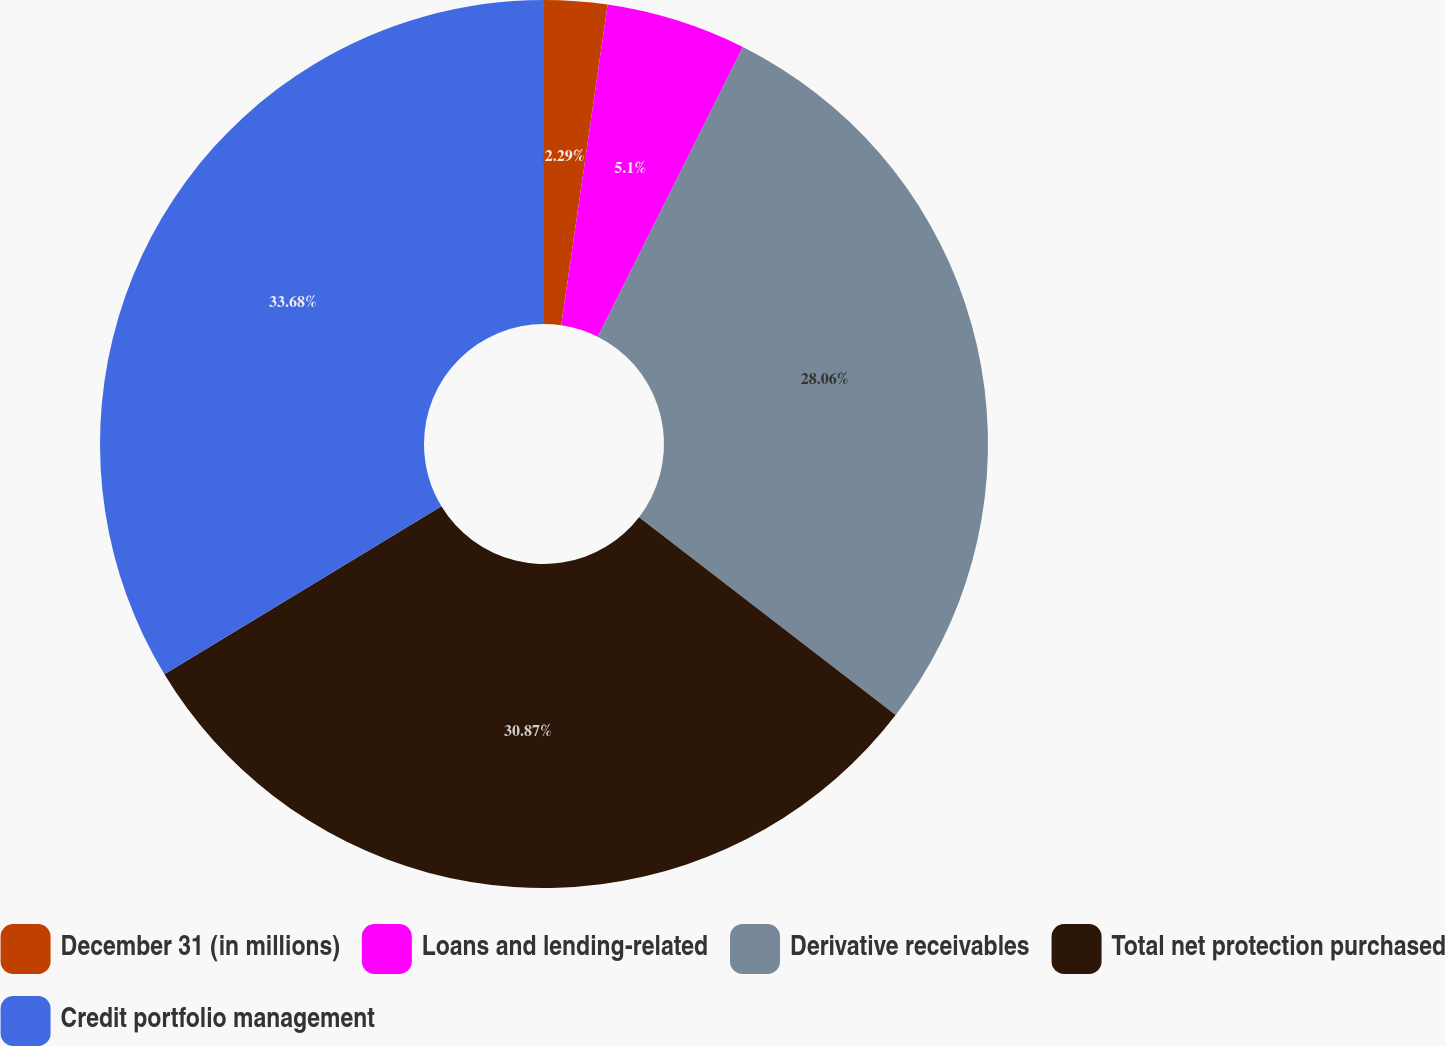<chart> <loc_0><loc_0><loc_500><loc_500><pie_chart><fcel>December 31 (in millions)<fcel>Loans and lending-related<fcel>Derivative receivables<fcel>Total net protection purchased<fcel>Credit portfolio management<nl><fcel>2.29%<fcel>5.1%<fcel>28.06%<fcel>30.87%<fcel>33.68%<nl></chart> 